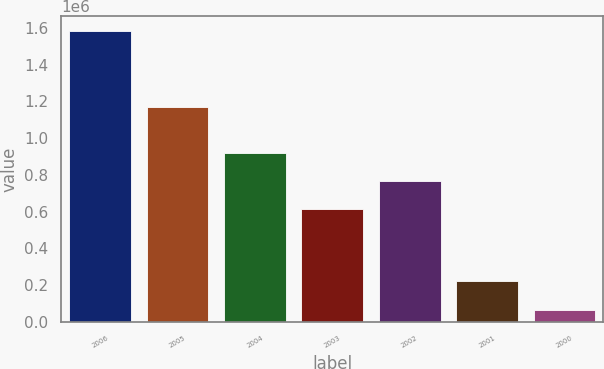<chart> <loc_0><loc_0><loc_500><loc_500><bar_chart><fcel>2006<fcel>2005<fcel>2004<fcel>2003<fcel>2002<fcel>2001<fcel>2000<nl><fcel>1.5836e+06<fcel>1.1714e+06<fcel>916590<fcel>613100<fcel>764845<fcel>223800<fcel>66150<nl></chart> 